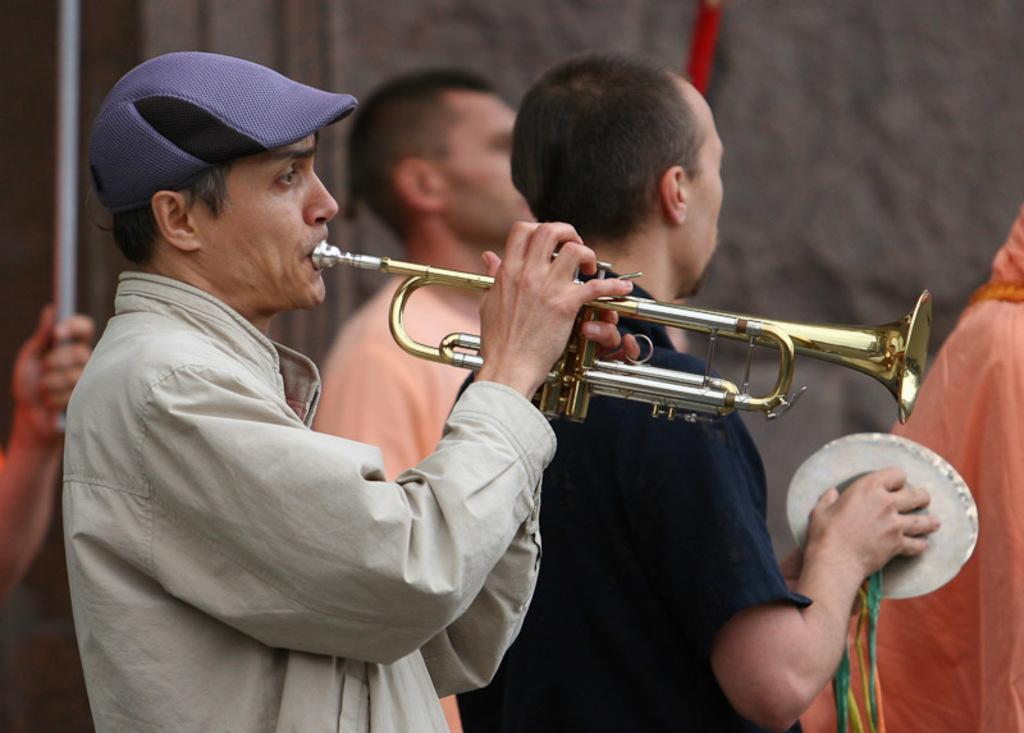What is happening in the image? There are people in the image, and a man is playing a trumpet. Can you describe the man playing the trumpet? The man is wearing a cap. What can be seen in the background of the image? There is a wall in the background of the image. What type of calculator is the man using while playing the trumpet? There is no calculator present in the image; the man is playing a trumpet without any additional devices. 